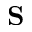<formula> <loc_0><loc_0><loc_500><loc_500>S</formula> 